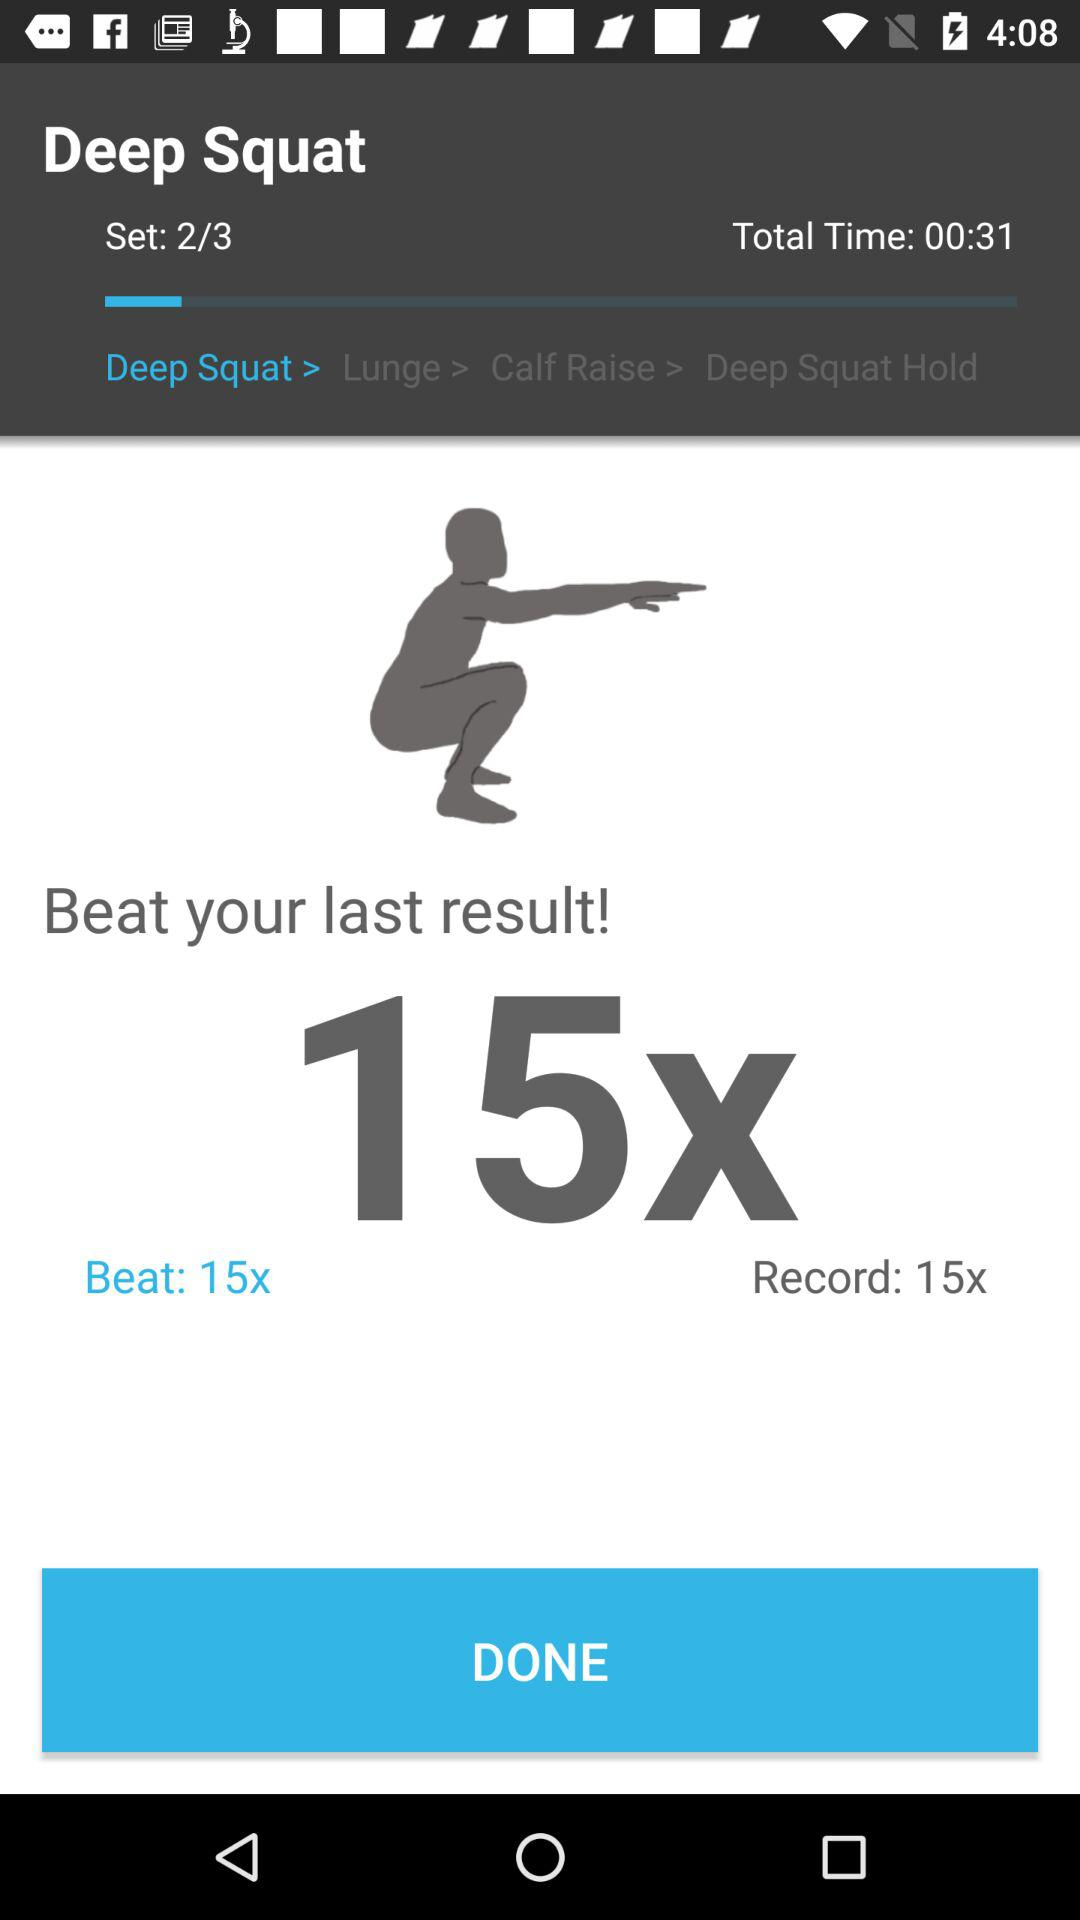How many sets are there in this workout?
Answer the question using a single word or phrase. 3 